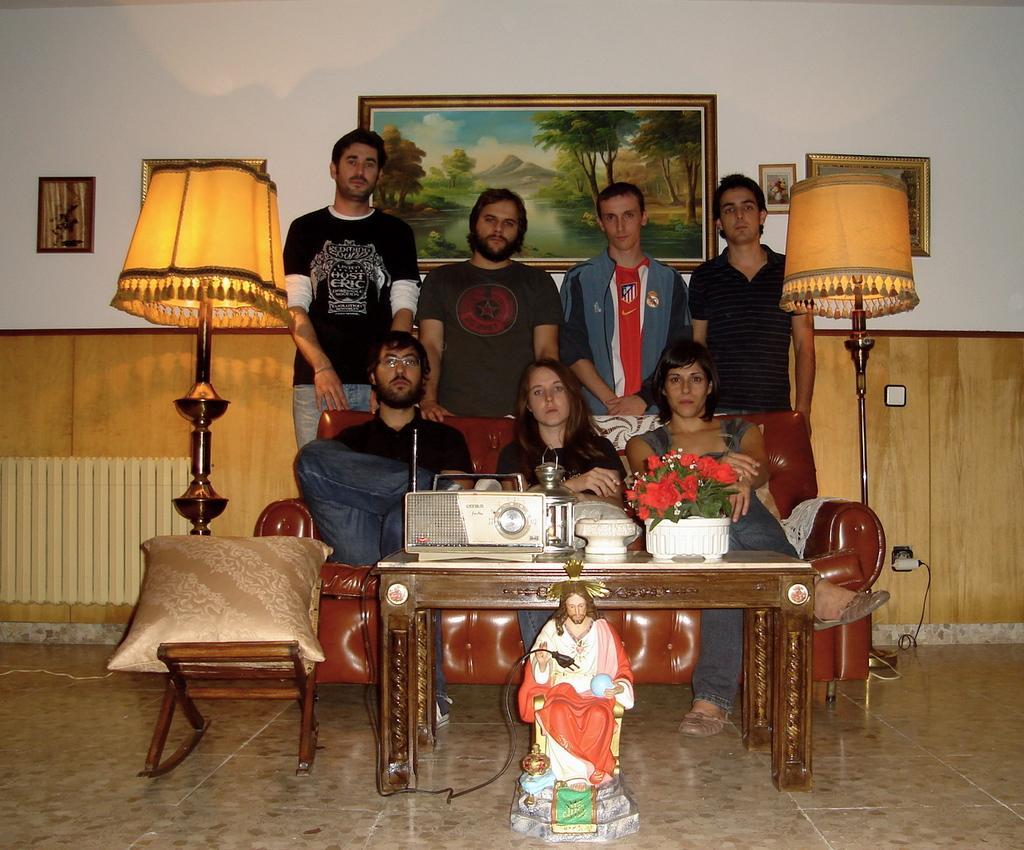How would you summarize this image in a sentence or two? This image consists of few things. In the middle of the image there are seven people, four were standing and three were sitting in a sofa. There is a table and on top of it there is a flower vase, radio and a lamp on it. In the left side of the image there is a lamp and a chair. At the background there is a wall and there were few frames on it. 